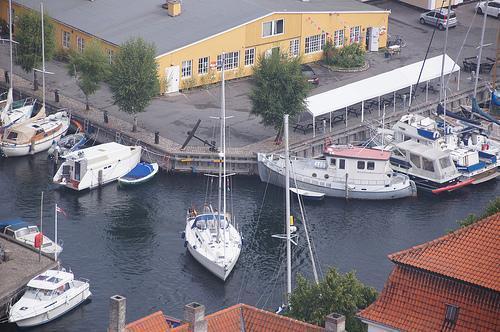How many chimneys are in the photo?
Give a very brief answer. 4. 